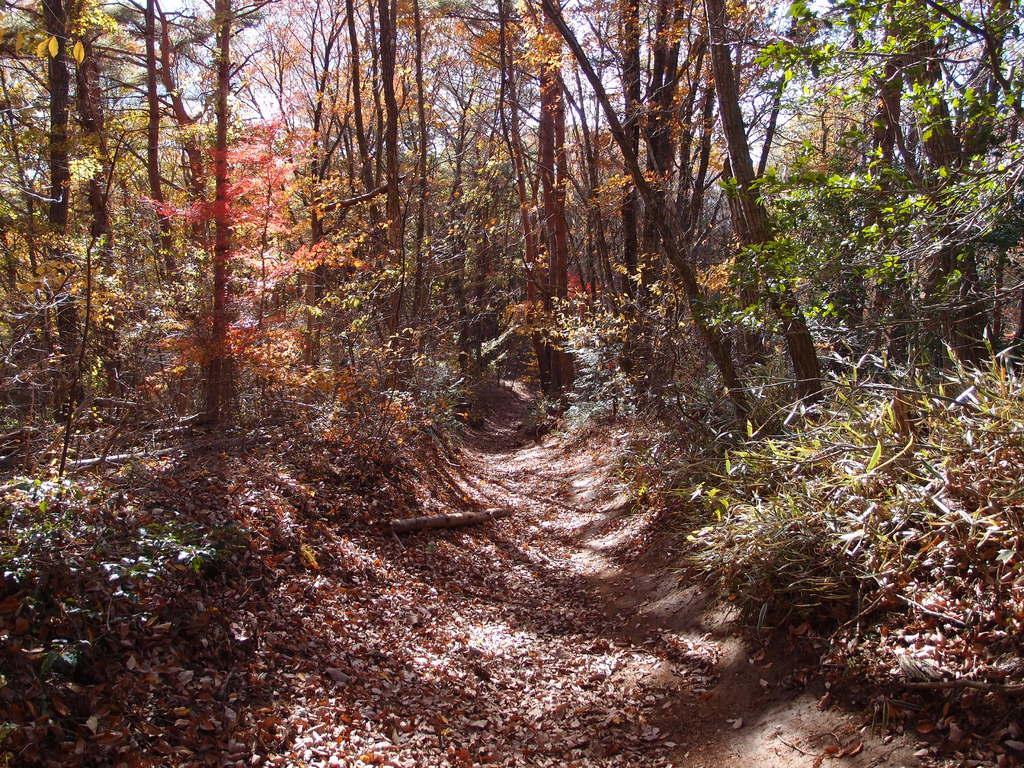How would you summarize this image in a sentence or two? In this image there is the sky towards the top of the image, there are trees, there are plants, there is ground towards the bottom of the image, there are leaves on the ground. 